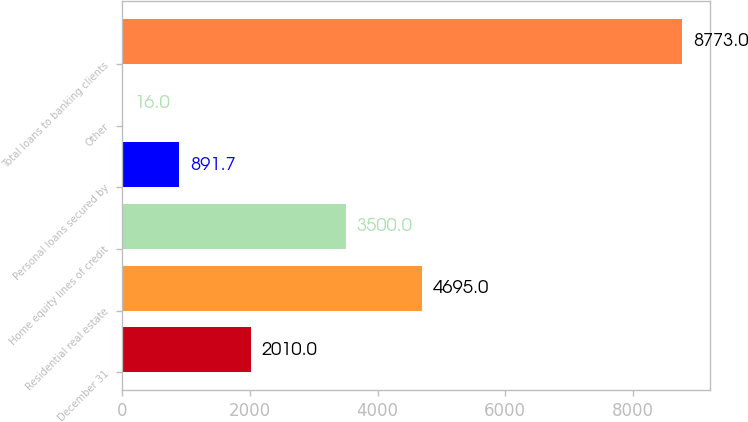Convert chart. <chart><loc_0><loc_0><loc_500><loc_500><bar_chart><fcel>December 31<fcel>Residential real estate<fcel>Home equity lines of credit<fcel>Personal loans secured by<fcel>Other<fcel>Total loans to banking clients<nl><fcel>2010<fcel>4695<fcel>3500<fcel>891.7<fcel>16<fcel>8773<nl></chart> 